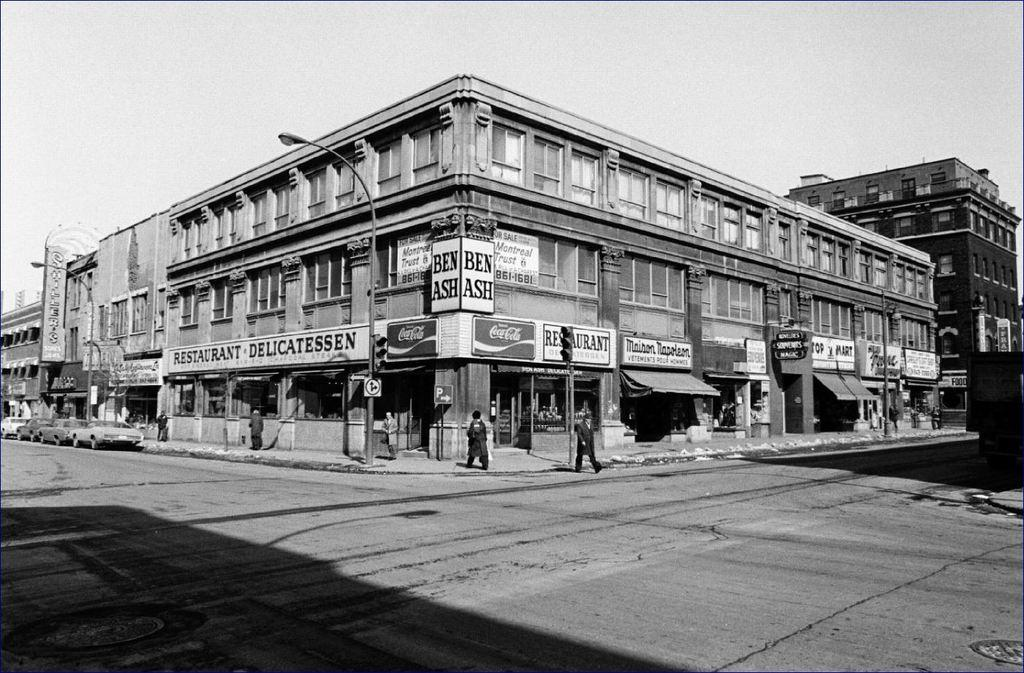<image>
Provide a brief description of the given image. City view with a "BEN ASH" store in the corner. 